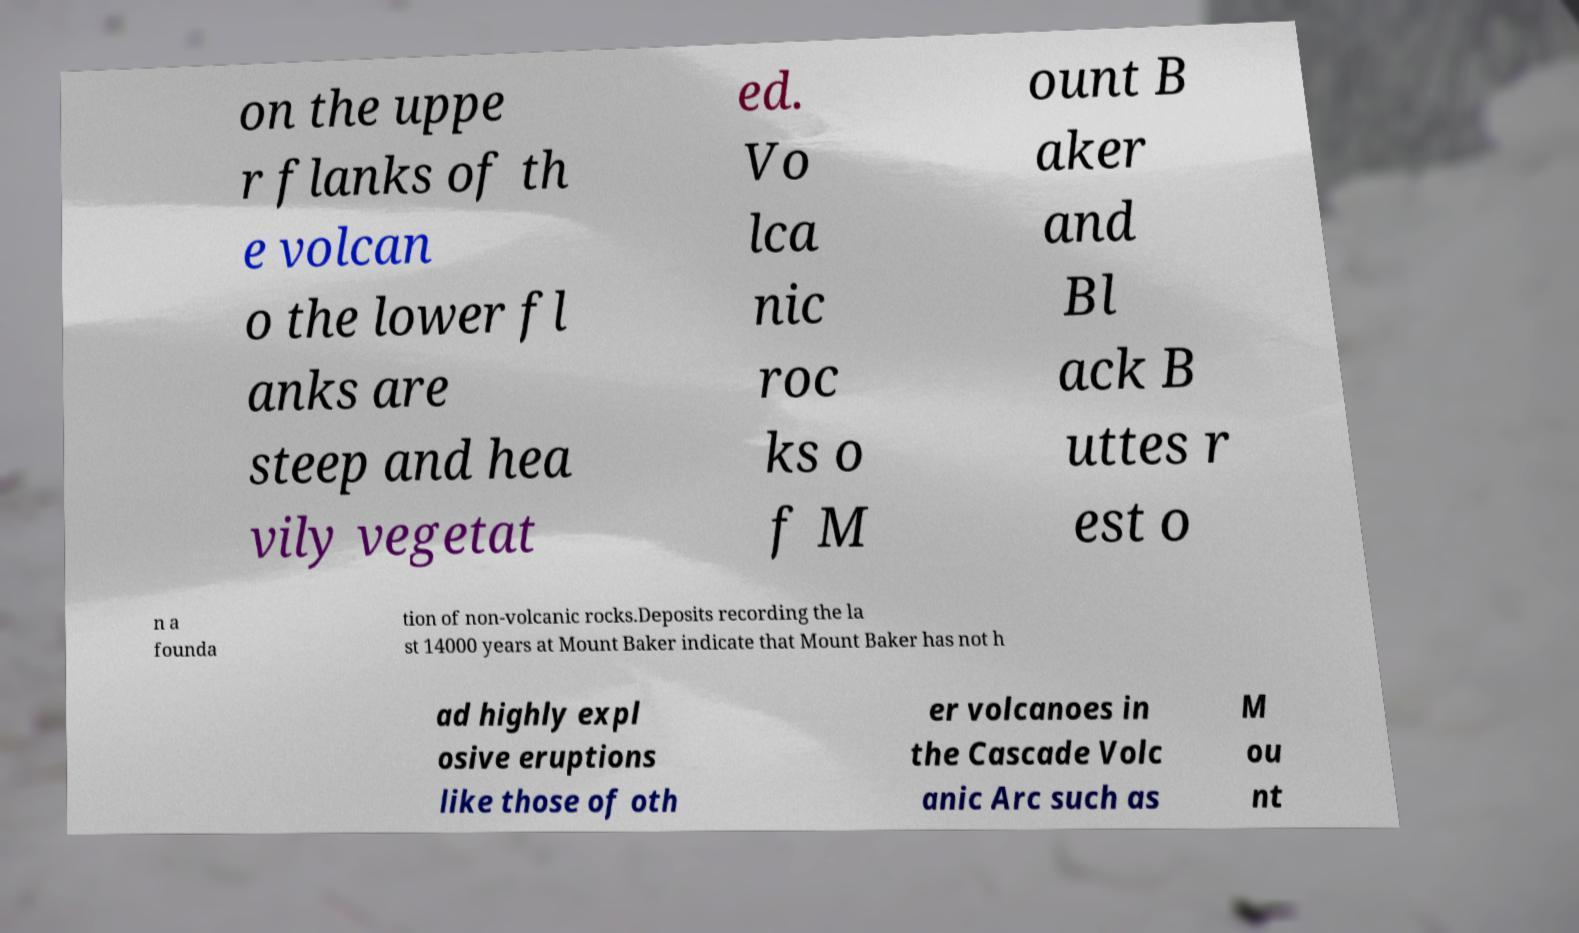For documentation purposes, I need the text within this image transcribed. Could you provide that? on the uppe r flanks of th e volcan o the lower fl anks are steep and hea vily vegetat ed. Vo lca nic roc ks o f M ount B aker and Bl ack B uttes r est o n a founda tion of non-volcanic rocks.Deposits recording the la st 14000 years at Mount Baker indicate that Mount Baker has not h ad highly expl osive eruptions like those of oth er volcanoes in the Cascade Volc anic Arc such as M ou nt 